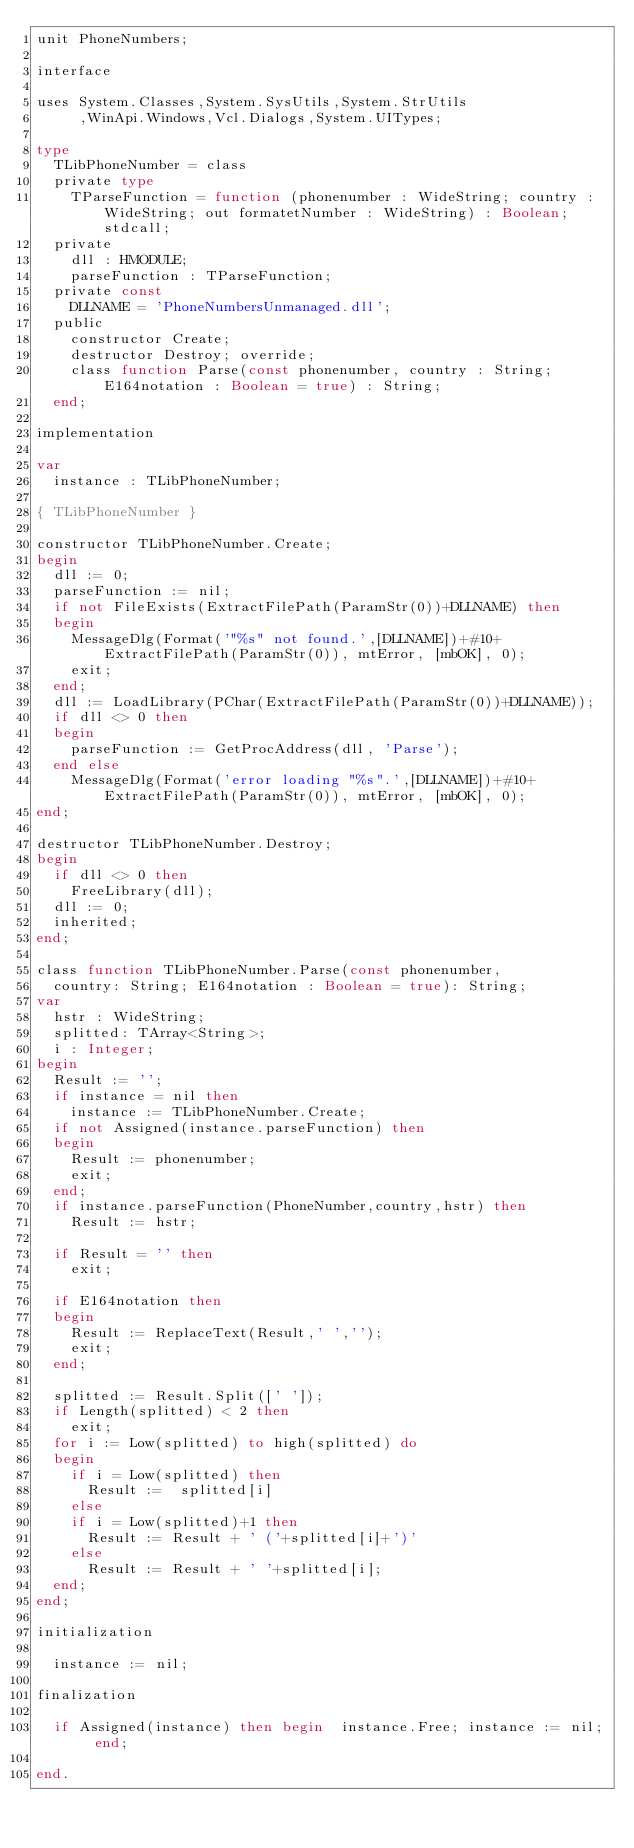<code> <loc_0><loc_0><loc_500><loc_500><_Pascal_>unit PhoneNumbers;

interface

uses System.Classes,System.SysUtils,System.StrUtils
     ,WinApi.Windows,Vcl.Dialogs,System.UITypes;

type
  TLibPhoneNumber = class
  private type
    TParseFunction = function (phonenumber : WideString; country : WideString; out formatetNumber : WideString) : Boolean; stdcall;
  private
    dll : HMODULE;
    parseFunction : TParseFunction;
  private const
    DLLNAME = 'PhoneNumbersUnmanaged.dll';
  public
    constructor Create;
    destructor Destroy; override;
    class function Parse(const phonenumber, country : String; E164notation : Boolean = true) : String;
  end;

implementation

var
  instance : TLibPhoneNumber;

{ TLibPhoneNumber }

constructor TLibPhoneNumber.Create;
begin
  dll := 0;
  parseFunction := nil;
  if not FileExists(ExtractFilePath(ParamStr(0))+DLLNAME) then
  begin
    MessageDlg(Format('"%s" not found.',[DLLNAME])+#10+ExtractFilePath(ParamStr(0)), mtError, [mbOK], 0);
    exit;
  end;
  dll := LoadLibrary(PChar(ExtractFilePath(ParamStr(0))+DLLNAME));
  if dll <> 0 then
  begin
    parseFunction := GetProcAddress(dll, 'Parse');
  end else
    MessageDlg(Format('error loading "%s".',[DLLNAME])+#10+ExtractFilePath(ParamStr(0)), mtError, [mbOK], 0);
end;

destructor TLibPhoneNumber.Destroy;
begin
  if dll <> 0 then
    FreeLibrary(dll);
  dll := 0;
  inherited;
end;

class function TLibPhoneNumber.Parse(const phonenumber,
  country: String; E164notation : Boolean = true): String;
var
  hstr : WideString;
  splitted: TArray<String>;
  i : Integer;
begin
  Result := '';
  if instance = nil then
    instance := TLibPhoneNumber.Create;
  if not Assigned(instance.parseFunction) then
  begin
    Result := phonenumber;
    exit;
  end;
  if instance.parseFunction(PhoneNumber,country,hstr) then
    Result := hstr;

  if Result = '' then
    exit;

  if E164notation then
  begin
    Result := ReplaceText(Result,' ','');
    exit;
  end;

  splitted := Result.Split([' ']);
  if Length(splitted) < 2 then
    exit;
  for i := Low(splitted) to high(splitted) do
  begin
    if i = Low(splitted) then
      Result :=  splitted[i]
    else
    if i = Low(splitted)+1 then
      Result := Result + ' ('+splitted[i]+')'
    else
      Result := Result + ' '+splitted[i];
  end;
end;

initialization

  instance := nil;

finalization

  if Assigned(instance) then begin  instance.Free; instance := nil; end;

end.

</code> 